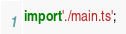<code> <loc_0><loc_0><loc_500><loc_500><_TypeScript_>import './main.ts';</code> 